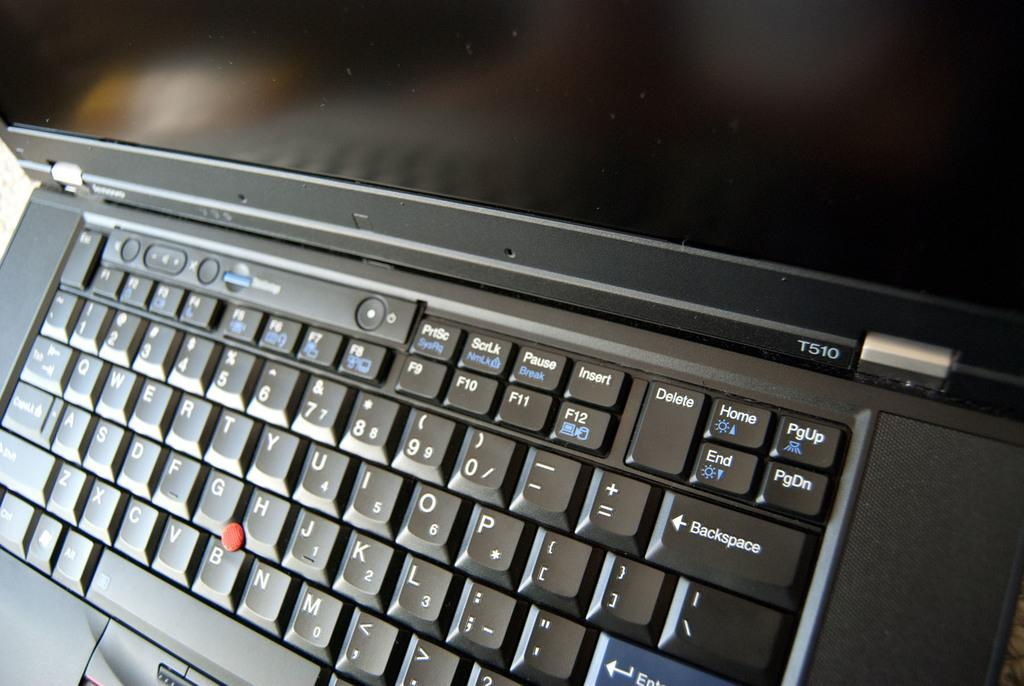<image>
Share a concise interpretation of the image provided. Laptop computer with the model number of T510. 